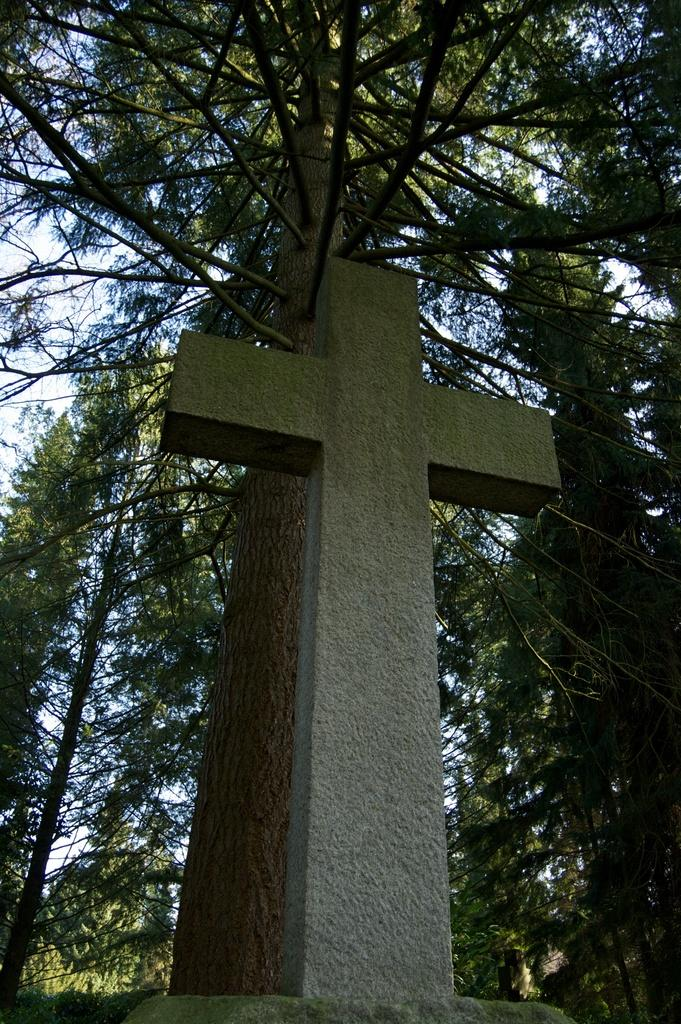What is the main subject of the image? There is a cross in the image. What can be seen in the background of the image? There are trees and the sky visible in the background of the image. What type of railway is visible in the image? There is no railway present in the image; it features a cross and a background with trees and the sky. How many balls are being used in the voyage depicted in the image? There is no voyage or balls present in the image; it features a cross and a background with trees and the sky. 